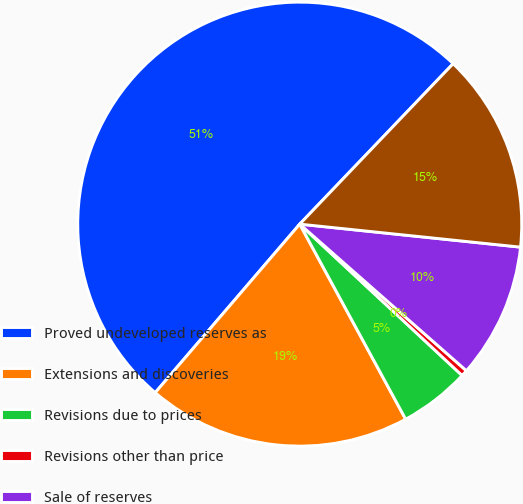Convert chart to OTSL. <chart><loc_0><loc_0><loc_500><loc_500><pie_chart><fcel>Proved undeveloped reserves as<fcel>Extensions and discoveries<fcel>Revisions due to prices<fcel>Revisions other than price<fcel>Sale of reserves<fcel>Conversion to proved developed<nl><fcel>50.86%<fcel>19.2%<fcel>5.14%<fcel>0.46%<fcel>9.83%<fcel>14.51%<nl></chart> 